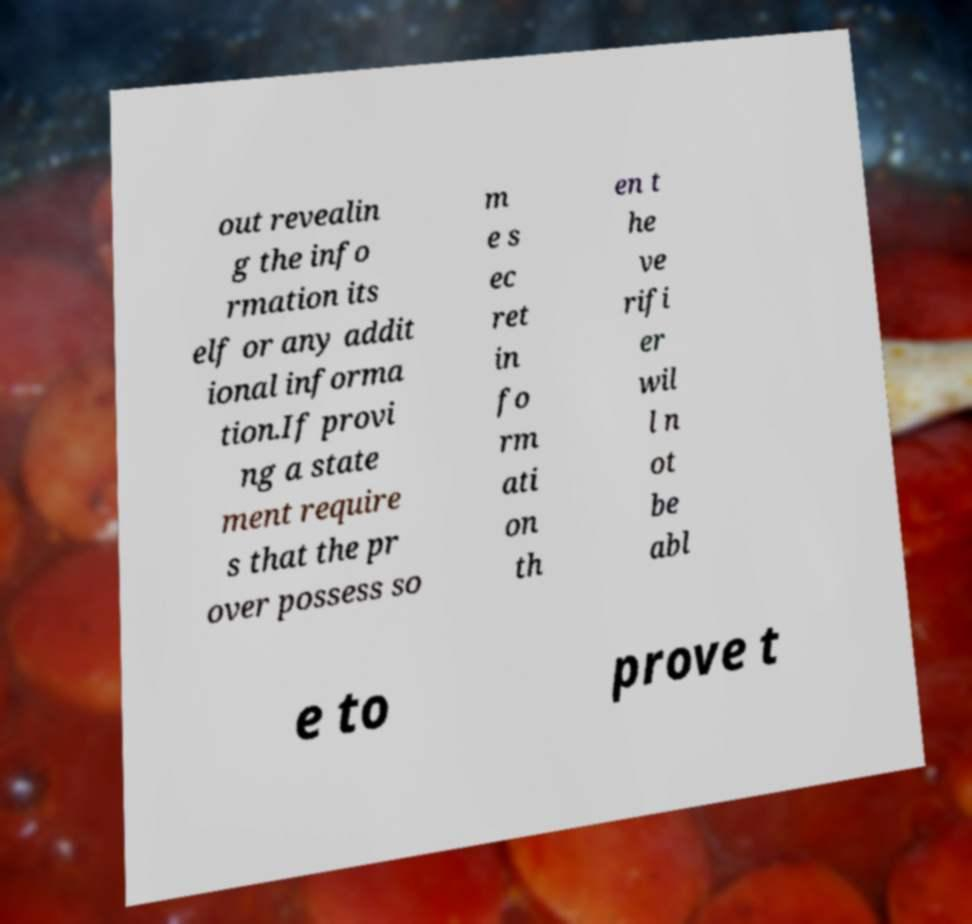Could you assist in decoding the text presented in this image and type it out clearly? out revealin g the info rmation its elf or any addit ional informa tion.If provi ng a state ment require s that the pr over possess so m e s ec ret in fo rm ati on th en t he ve rifi er wil l n ot be abl e to prove t 